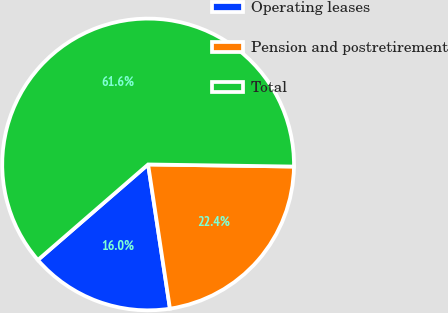Convert chart. <chart><loc_0><loc_0><loc_500><loc_500><pie_chart><fcel>Operating leases<fcel>Pension and postretirement<fcel>Total<nl><fcel>16.03%<fcel>22.38%<fcel>61.6%<nl></chart> 